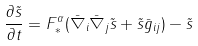Convert formula to latex. <formula><loc_0><loc_0><loc_500><loc_500>\frac { \partial \tilde { s } } { \partial t } = F _ { * } ^ { \alpha } ( \bar { \nabla } _ { i } \bar { \nabla } _ { j } \tilde { s } + \tilde { s } \bar { g } _ { i j } ) - \tilde { s }</formula> 